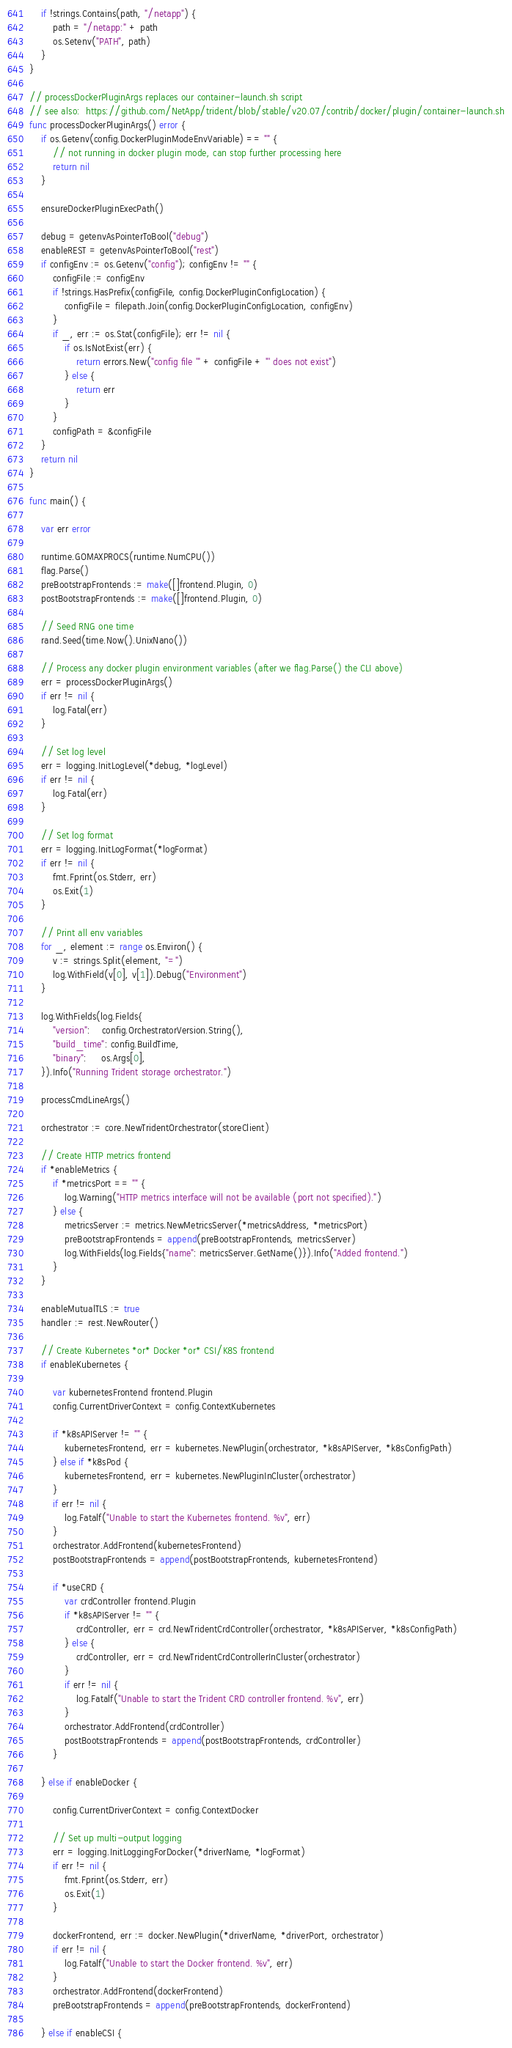<code> <loc_0><loc_0><loc_500><loc_500><_Go_>	if !strings.Contains(path, "/netapp") {
		path = "/netapp:" + path
		os.Setenv("PATH", path)
	}
}

// processDockerPluginArgs replaces our container-launch.sh script
// see also:  https://github.com/NetApp/trident/blob/stable/v20.07/contrib/docker/plugin/container-launch.sh
func processDockerPluginArgs() error {
	if os.Getenv(config.DockerPluginModeEnvVariable) == "" {
		// not running in docker plugin mode, can stop further processing here
		return nil
	}

	ensureDockerPluginExecPath()

	debug = getenvAsPointerToBool("debug")
	enableREST = getenvAsPointerToBool("rest")
	if configEnv := os.Getenv("config"); configEnv != "" {
		configFile := configEnv
		if !strings.HasPrefix(configFile, config.DockerPluginConfigLocation) {
			configFile = filepath.Join(config.DockerPluginConfigLocation, configEnv)
		}
		if _, err := os.Stat(configFile); err != nil {
			if os.IsNotExist(err) {
				return errors.New("config file '" + configFile + "' does not exist")
			} else {
				return err
			}
		}
		configPath = &configFile
	}
	return nil
}

func main() {

	var err error

	runtime.GOMAXPROCS(runtime.NumCPU())
	flag.Parse()
	preBootstrapFrontends := make([]frontend.Plugin, 0)
	postBootstrapFrontends := make([]frontend.Plugin, 0)

	// Seed RNG one time
	rand.Seed(time.Now().UnixNano())

	// Process any docker plugin environment variables (after we flag.Parse() the CLI above)
	err = processDockerPluginArgs()
	if err != nil {
		log.Fatal(err)
	}

	// Set log level
	err = logging.InitLogLevel(*debug, *logLevel)
	if err != nil {
		log.Fatal(err)
	}

	// Set log format
	err = logging.InitLogFormat(*logFormat)
	if err != nil {
		fmt.Fprint(os.Stderr, err)
		os.Exit(1)
	}

	// Print all env variables
	for _, element := range os.Environ() {
		v := strings.Split(element, "=")
		log.WithField(v[0], v[1]).Debug("Environment")
	}

	log.WithFields(log.Fields{
		"version":    config.OrchestratorVersion.String(),
		"build_time": config.BuildTime,
		"binary":     os.Args[0],
	}).Info("Running Trident storage orchestrator.")

	processCmdLineArgs()

	orchestrator := core.NewTridentOrchestrator(storeClient)

	// Create HTTP metrics frontend
	if *enableMetrics {
		if *metricsPort == "" {
			log.Warning("HTTP metrics interface will not be available (port not specified).")
		} else {
			metricsServer := metrics.NewMetricsServer(*metricsAddress, *metricsPort)
			preBootstrapFrontends = append(preBootstrapFrontends, metricsServer)
			log.WithFields(log.Fields{"name": metricsServer.GetName()}).Info("Added frontend.")
		}
	}

	enableMutualTLS := true
	handler := rest.NewRouter()

	// Create Kubernetes *or* Docker *or* CSI/K8S frontend
	if enableKubernetes {

		var kubernetesFrontend frontend.Plugin
		config.CurrentDriverContext = config.ContextKubernetes

		if *k8sAPIServer != "" {
			kubernetesFrontend, err = kubernetes.NewPlugin(orchestrator, *k8sAPIServer, *k8sConfigPath)
		} else if *k8sPod {
			kubernetesFrontend, err = kubernetes.NewPluginInCluster(orchestrator)
		}
		if err != nil {
			log.Fatalf("Unable to start the Kubernetes frontend. %v", err)
		}
		orchestrator.AddFrontend(kubernetesFrontend)
		postBootstrapFrontends = append(postBootstrapFrontends, kubernetesFrontend)

		if *useCRD {
			var crdController frontend.Plugin
			if *k8sAPIServer != "" {
				crdController, err = crd.NewTridentCrdController(orchestrator, *k8sAPIServer, *k8sConfigPath)
			} else {
				crdController, err = crd.NewTridentCrdControllerInCluster(orchestrator)
			}
			if err != nil {
				log.Fatalf("Unable to start the Trident CRD controller frontend. %v", err)
			}
			orchestrator.AddFrontend(crdController)
			postBootstrapFrontends = append(postBootstrapFrontends, crdController)
		}

	} else if enableDocker {

		config.CurrentDriverContext = config.ContextDocker

		// Set up multi-output logging
		err = logging.InitLoggingForDocker(*driverName, *logFormat)
		if err != nil {
			fmt.Fprint(os.Stderr, err)
			os.Exit(1)
		}

		dockerFrontend, err := docker.NewPlugin(*driverName, *driverPort, orchestrator)
		if err != nil {
			log.Fatalf("Unable to start the Docker frontend. %v", err)
		}
		orchestrator.AddFrontend(dockerFrontend)
		preBootstrapFrontends = append(preBootstrapFrontends, dockerFrontend)

	} else if enableCSI {
</code> 